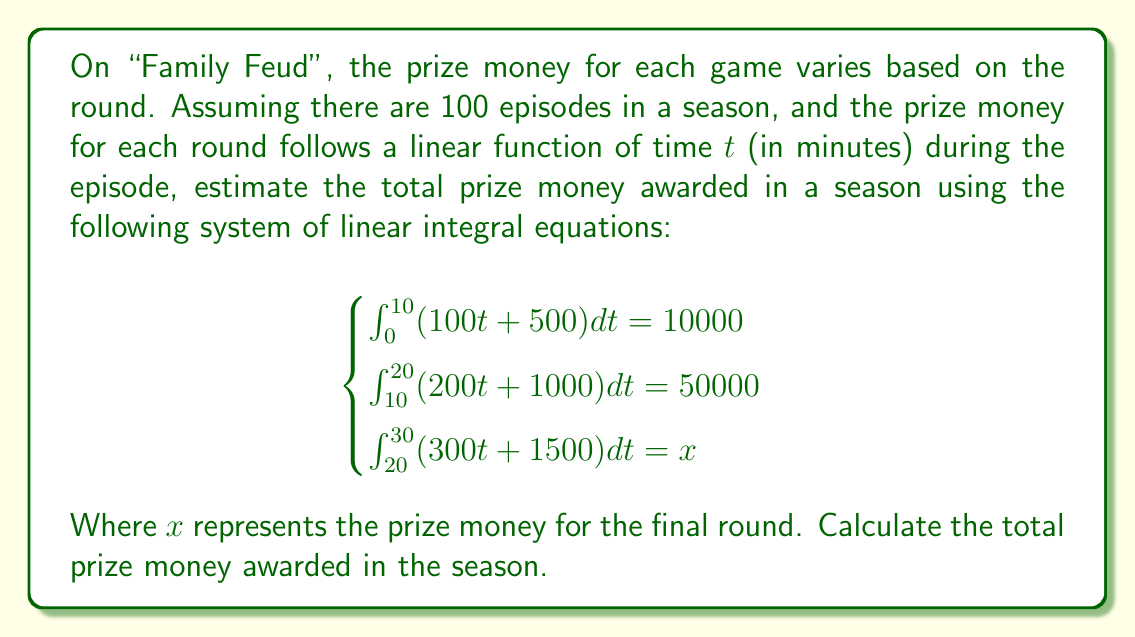Can you answer this question? Let's solve this step-by-step:

1) First, we need to solve the system of equations to find $x$.

2) For the first equation:
   $$\int_0^{10} (100t + 500) dt = 10000$$
   $$[50t^2 + 500t]_0^{10} = 10000$$
   $$5000 + 5000 - 0 = 10000$$ (This checks out)

3) For the second equation:
   $$\int_{10}^{20} (200t + 1000) dt = 50000$$
   $$[100t^2 + 1000t]_{10}^{20} = 50000$$
   $$(40000 + 20000) - (10000 + 10000) = 50000$$ (This also checks out)

4) For the third equation:
   $$\int_{20}^{30} (300t + 1500) dt = x$$
   $$[150t^2 + 1500t]_{20}^{30} = x$$
   $$(135000 + 45000) - (60000 + 30000) = x$$
   $$90000 = x$$

5) Now that we have the prize money for each round, we can calculate the total for one episode:
   $10000 + 50000 + 90000 = 150000$

6) For a season of 100 episodes, the total prize money would be:
   $150000 * 100 = 15000000$

Therefore, the total prize money awarded in the season is $15,000,000.
Answer: $15,000,000 